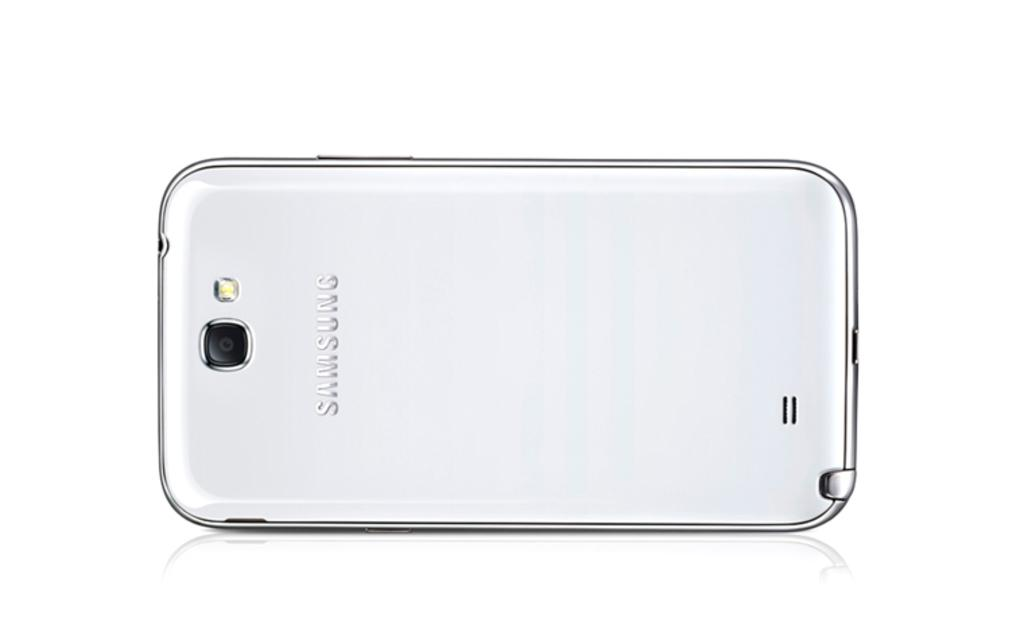<image>
Write a terse but informative summary of the picture. A silver Samsung phone is face down showing a camera and flash bulb on a white surface. 